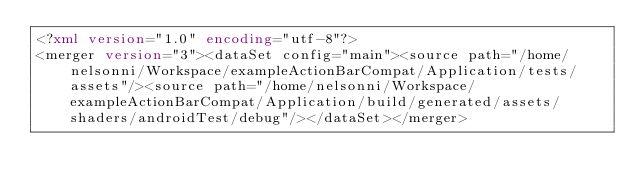Convert code to text. <code><loc_0><loc_0><loc_500><loc_500><_XML_><?xml version="1.0" encoding="utf-8"?>
<merger version="3"><dataSet config="main"><source path="/home/nelsonni/Workspace/exampleActionBarCompat/Application/tests/assets"/><source path="/home/nelsonni/Workspace/exampleActionBarCompat/Application/build/generated/assets/shaders/androidTest/debug"/></dataSet></merger></code> 